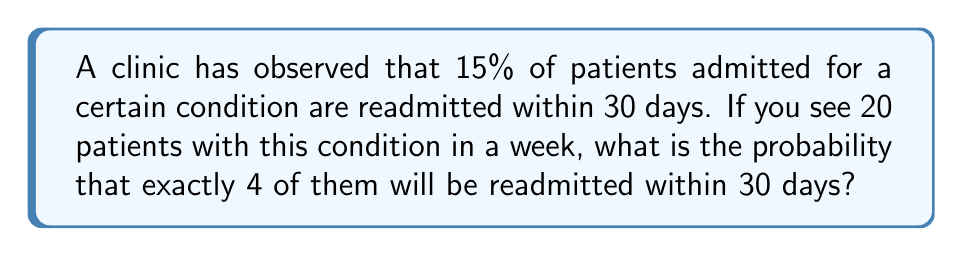Can you answer this question? To solve this problem, we'll use the binomial probability formula, as we're dealing with a fixed number of independent trials (patients) with a constant probability of success (readmission).

1. Identify the parameters:
   $n = 20$ (number of patients)
   $k = 4$ (number of readmissions we're interested in)
   $p = 0.15$ (probability of readmission for each patient)
   $q = 1 - p = 0.85$ (probability of no readmission)

2. Use the binomial probability formula:
   $$P(X = k) = \binom{n}{k} p^k q^{n-k}$$

3. Calculate the binomial coefficient:
   $$\binom{20}{4} = \frac{20!}{4!(20-4)!} = \frac{20!}{4!16!} = 4845$$

4. Substitute values into the formula:
   $$P(X = 4) = 4845 \cdot (0.15)^4 \cdot (0.85)^{16}$$

5. Calculate the result:
   $$P(X = 4) = 4845 \cdot 0.0005063 \cdot 0.0434 \approx 0.1064$$

Therefore, the probability of exactly 4 patients being readmitted within 30 days is approximately 0.1064 or 10.64%.
Answer: $0.1064$ 